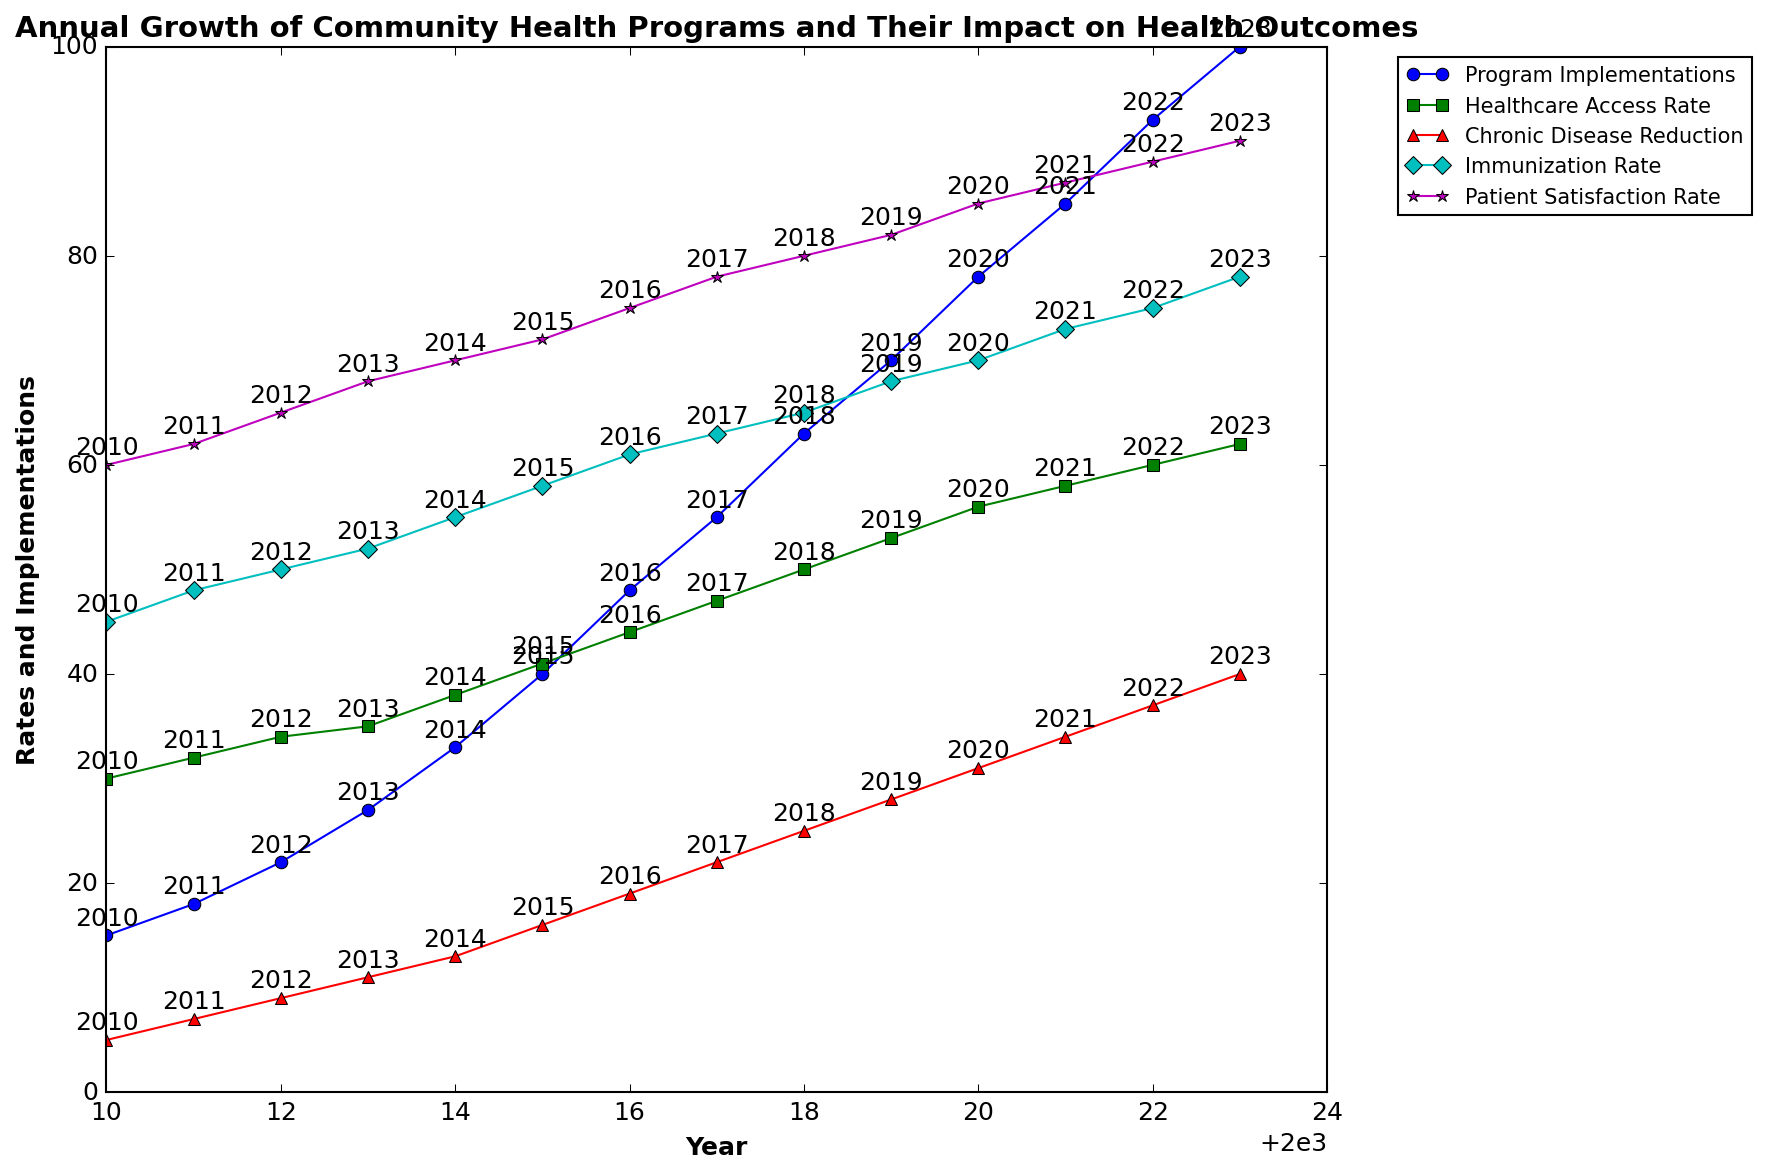What is the total number of program implementations in 2023? To find the total number of program implementations in 2023, refer to the 'Program Implementations' line at the year 2023.
Answer: 100 How does the immunization rate in 2016 compare to that in 2023? To compare the immunization rate in 2016 and 2023, look at the 'Immunization Rate' values for both years. In 2016, it is 61, and in 2023, it is 78.
Answer: Increased Which data point has the highest increase in healthcare access rate between any two consecutive years, and what is the increase? Identify the difference in healthcare access rate between consecutive years and find the highest one. The highest increase is between 2016 and 2017, where it goes from 44 to 47. The increase is 3.
Answer: 3 What is the average patient satisfaction rate over the period from 2010 to 2023? Calculate the sum of patient satisfaction rates from 2010 to 2023 and divide by the number of years (14 years). Sum = 60 + 62 + 65 + 68 + 70 + 72 + 75 + 78 + 80 + 82 + 85 + 87 + 89 + 91 = 1014. Average = 1014 / 14.
Answer: 72.43 Is there a year when the chronic disease reduction rate was equal to or greater than the healthcare access rate? Check each year to compare the 'Chronic Disease Reduction' and 'Healthcare Access Rate.' In 2023, Chronic Disease Reduction (40) is less than Healthcare Access Rate (62). So, there is no such year.
Answer: No In which year do program implementations appear to grow the most in a single year? Find the difference in program implementations between each year and locate the maximum. Maximum increase is between 2019 (70) and 2020 (78), with an increase of 8.
Answer: 2020 What is the color of the line representing the patient satisfaction rate in the plot? Refer to the plot legend to see the color corresponding to the 'Patient Satisfaction Rate' line.
Answer: Magenta Between which years did the healthcare access rate experience the largest percentage growth, and what was that percentage? Calculate the percentage growth for each consecutive year sequence. The largest percentage growth is between 2011 (32) and 2012 (34), with (34 - 32) / 32 * 100 = 6.25%.
Answer: 2011-2012, 6.25% What is the average annual increase in chronic disease reduction from 2010 to 2023? Calculate the total increase in chronic disease reduction from 2010 (5) to 2023 (40), which is 40 - 5 = 35. Divide this by the number of years (13 years). Average annual increase = 35 / 13.
Answer: 2.69 